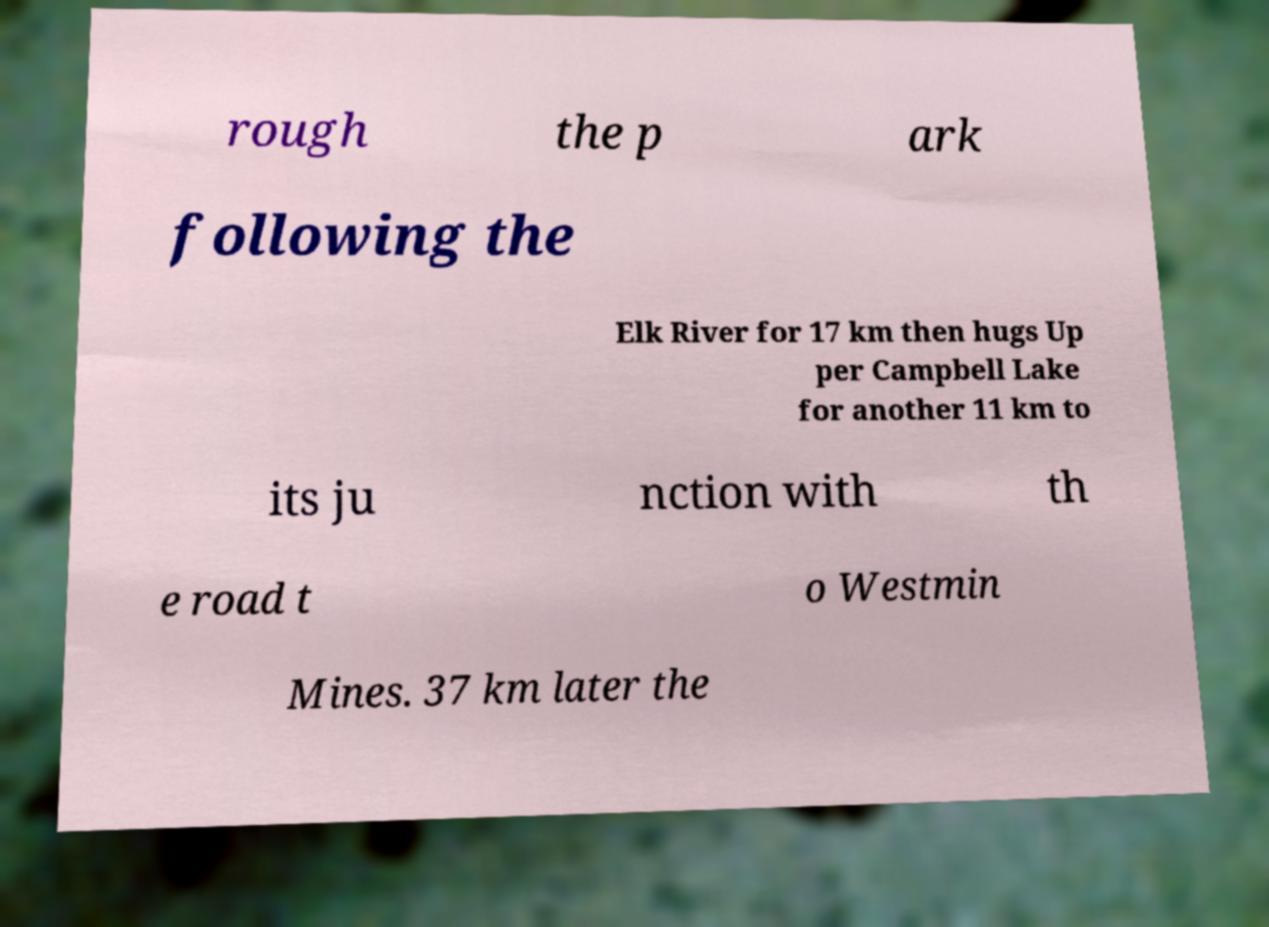I need the written content from this picture converted into text. Can you do that? rough the p ark following the Elk River for 17 km then hugs Up per Campbell Lake for another 11 km to its ju nction with th e road t o Westmin Mines. 37 km later the 